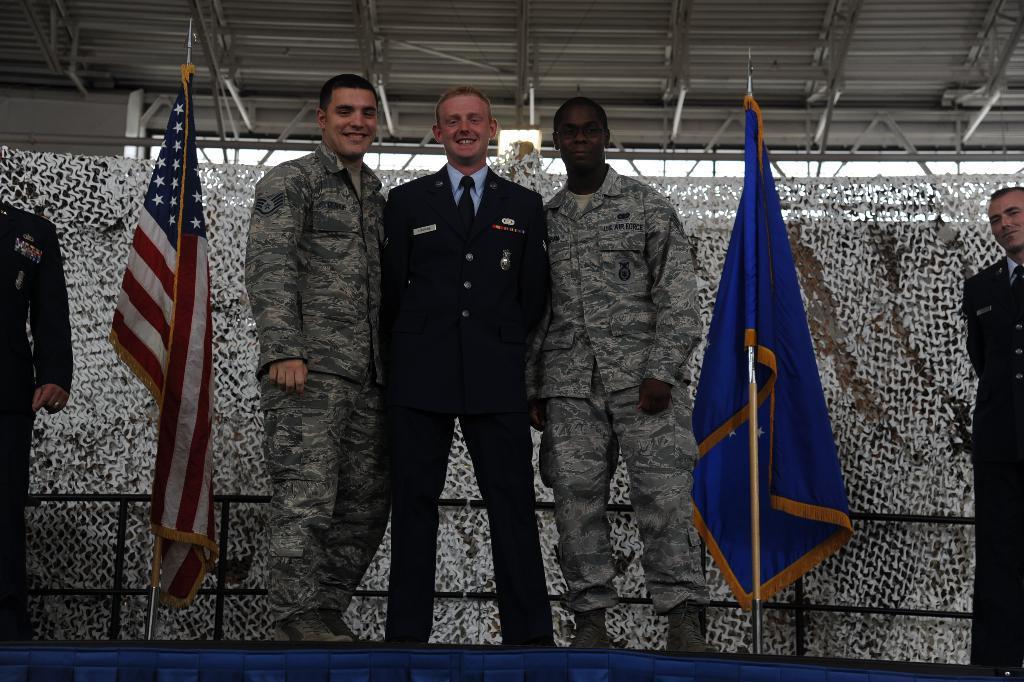Describe this image in one or two sentences. In this image we can see some people standing on the ground. In the background, we can see flags on the pole, railing and a net. At the top of the image we can see some poles and a shed. 